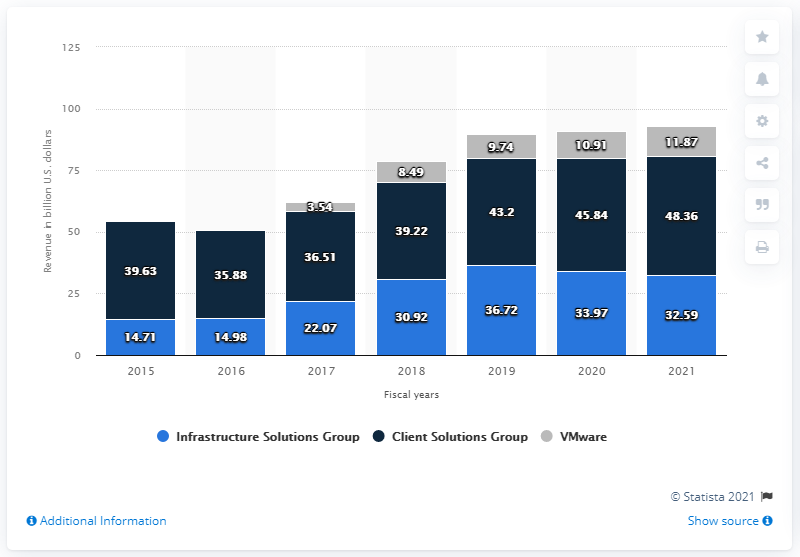Indicate a few pertinent items in this graphic. Dell Technologies generated $32.59 billion in revenue in the fiscal year 2021. 